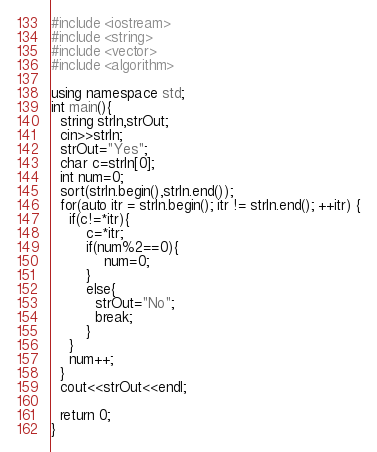<code> <loc_0><loc_0><loc_500><loc_500><_C++_>#include <iostream>
#include <string>
#include <vector> 
#include <algorithm>

using namespace std;
int main(){
  string strIn,strOut;
  cin>>strIn;
  strOut="Yes";
  char c=strIn[0];
  int num=0;
  sort(strIn.begin(),strIn.end());
  for(auto itr = strIn.begin(); itr != strIn.end(); ++itr) {
 	if(c!=*itr){
    	c=*itr;
    	if(num%2==0){
            num=0;
        }
        else{
          strOut="No";
          break;
        }
    }
    num++;
  }
  cout<<strOut<<endl;
  
  return 0;
}</code> 